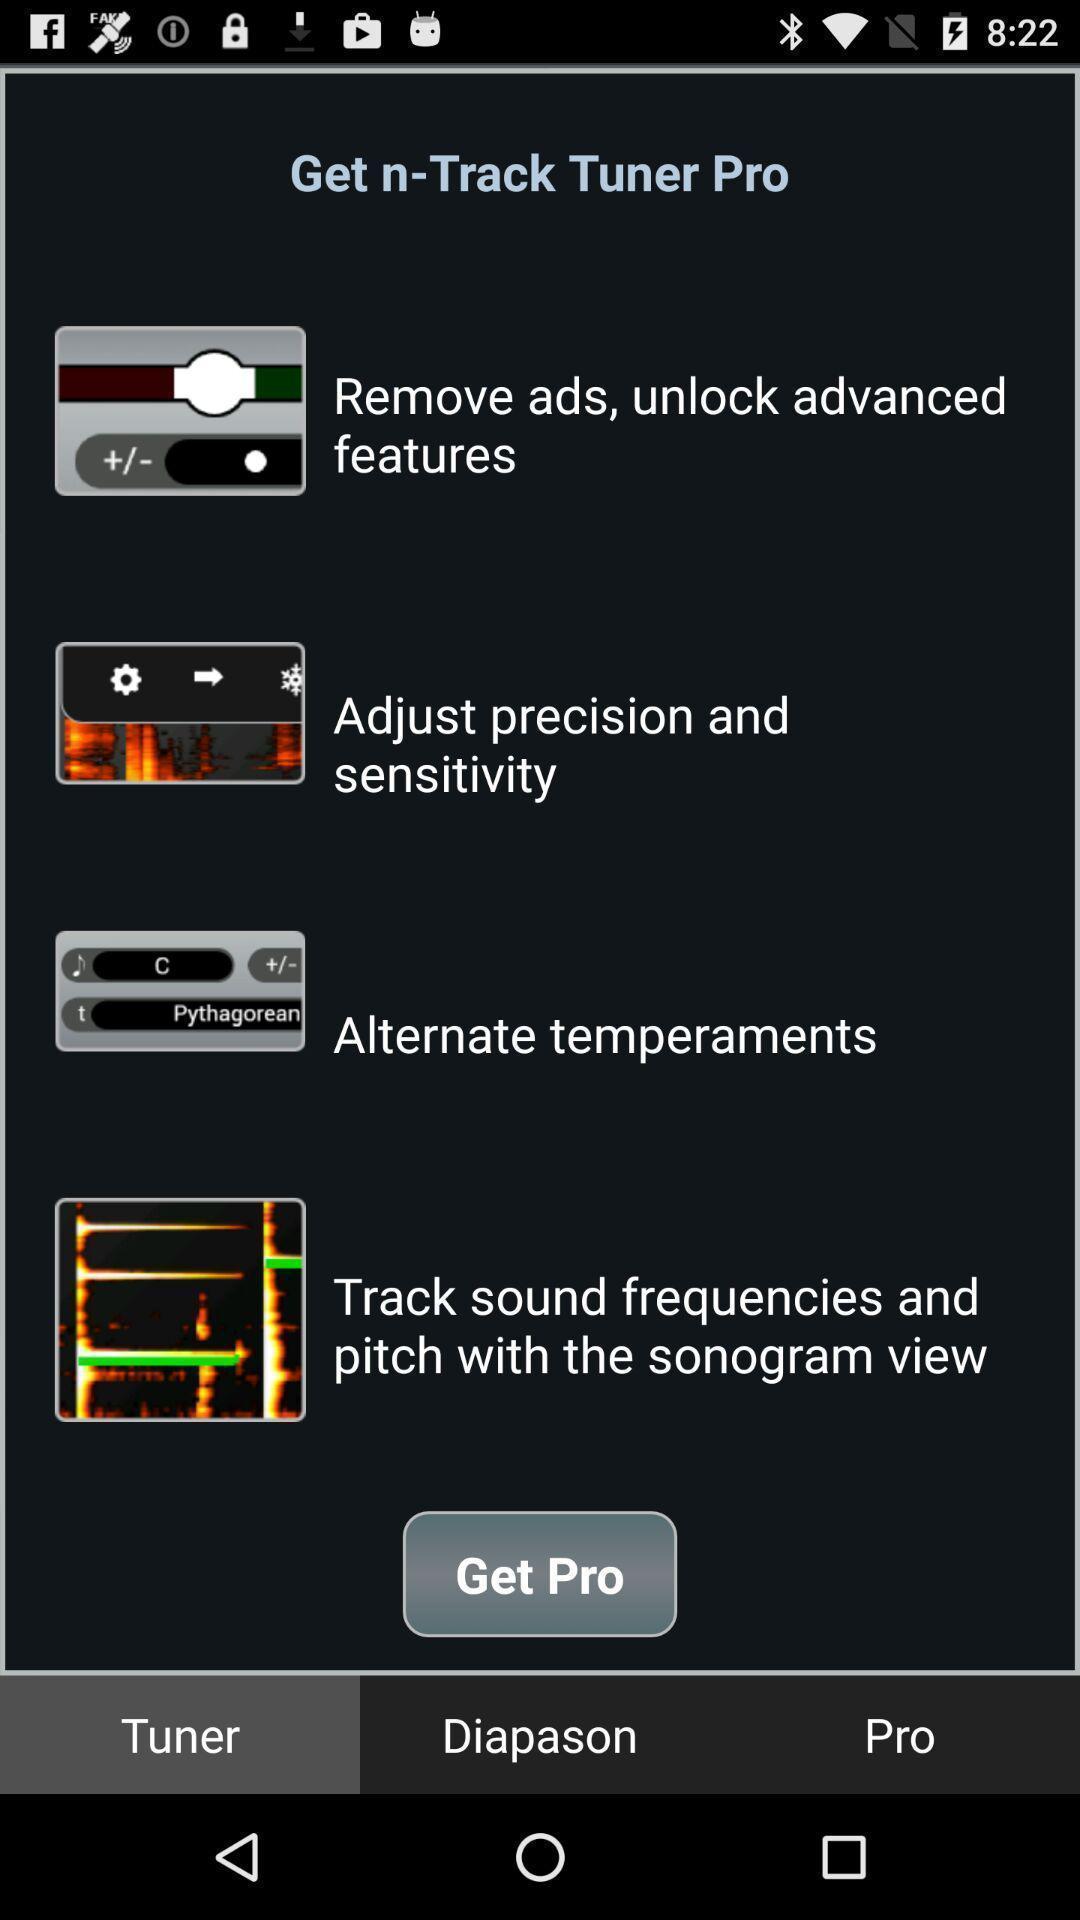Explain what's happening in this screen capture. Screen shows multiple options. 